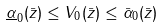<formula> <loc_0><loc_0><loc_500><loc_500>\underline { \alpha } _ { 0 } ( \| \bar { z } \| ) \leq V _ { 0 } ( \bar { z } ) \leq \bar { \alpha } _ { 0 } ( \| \bar { z } \| )</formula> 